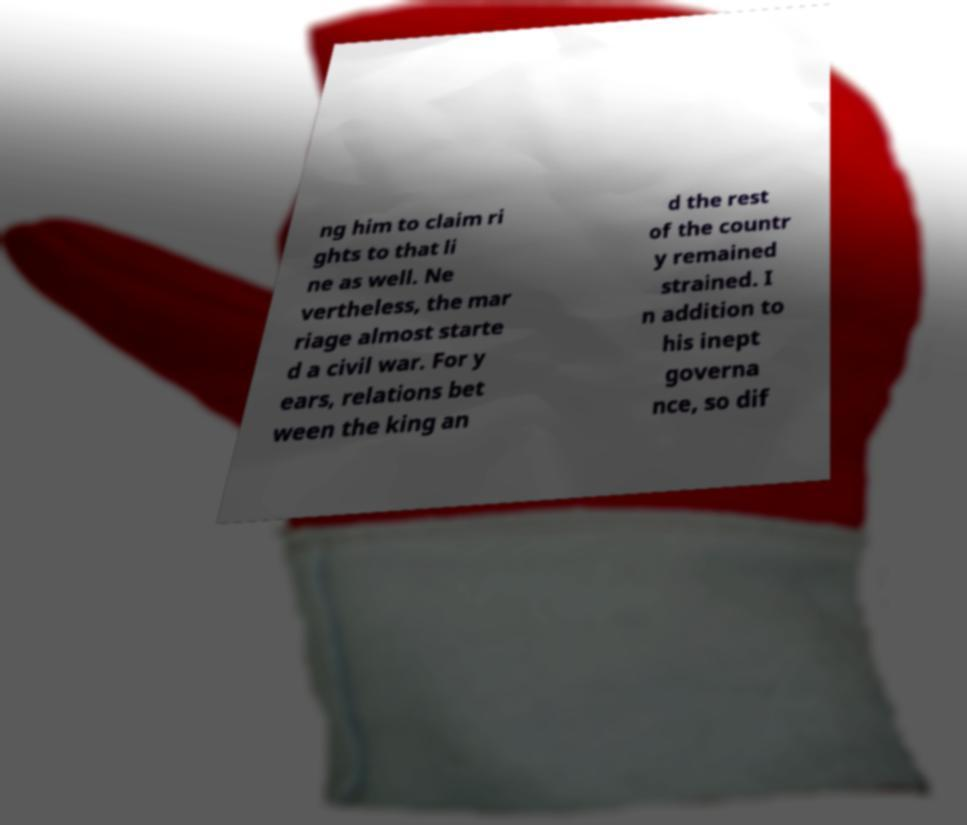Can you read and provide the text displayed in the image?This photo seems to have some interesting text. Can you extract and type it out for me? ng him to claim ri ghts to that li ne as well. Ne vertheless, the mar riage almost starte d a civil war. For y ears, relations bet ween the king an d the rest of the countr y remained strained. I n addition to his inept governa nce, so dif 